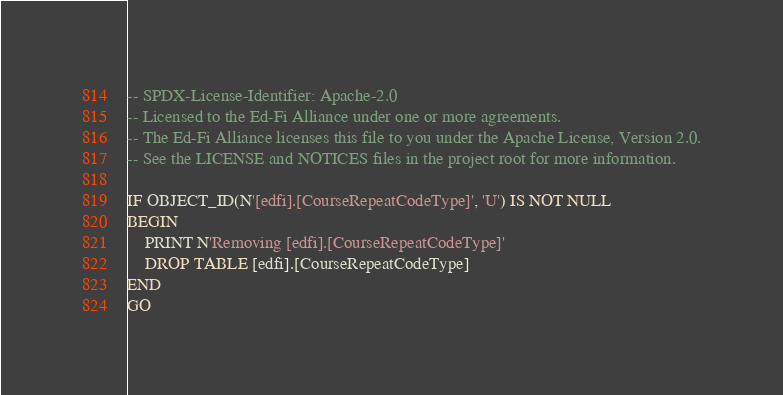Convert code to text. <code><loc_0><loc_0><loc_500><loc_500><_SQL_>-- SPDX-License-Identifier: Apache-2.0
-- Licensed to the Ed-Fi Alliance under one or more agreements.
-- The Ed-Fi Alliance licenses this file to you under the Apache License, Version 2.0.
-- See the LICENSE and NOTICES files in the project root for more information.

IF OBJECT_ID(N'[edfi].[CourseRepeatCodeType]', 'U') IS NOT NULL
BEGIN
	PRINT N'Removing [edfi].[CourseRepeatCodeType]'
	DROP TABLE [edfi].[CourseRepeatCodeType]
END
GO

</code> 